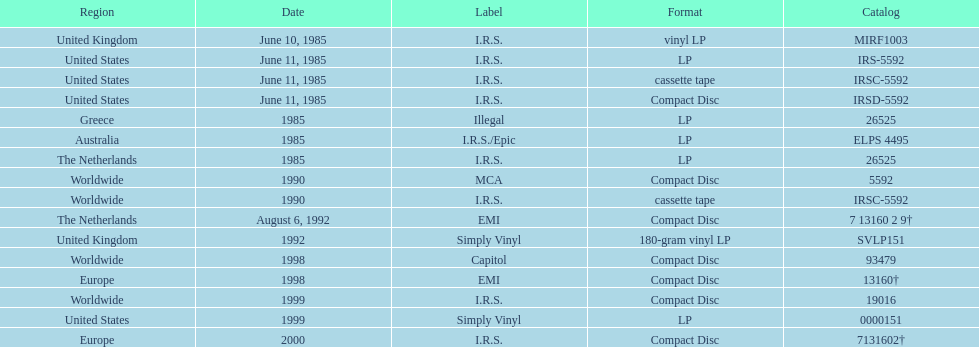In how many countries was the record released before the year 1990? 5. 